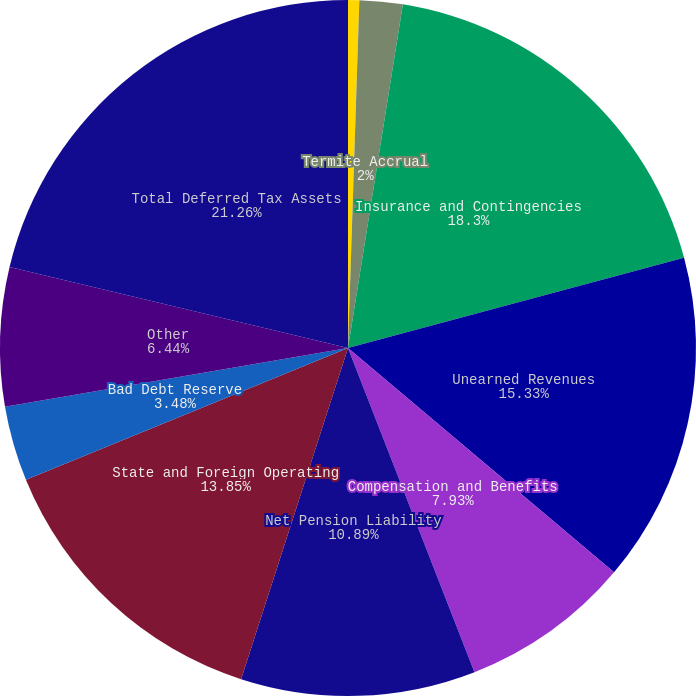Convert chart to OTSL. <chart><loc_0><loc_0><loc_500><loc_500><pie_chart><fcel>(in thousands)<fcel>Termite Accrual<fcel>Insurance and Contingencies<fcel>Unearned Revenues<fcel>Compensation and Benefits<fcel>Net Pension Liability<fcel>State and Foreign Operating<fcel>Bad Debt Reserve<fcel>Other<fcel>Total Deferred Tax Assets<nl><fcel>0.52%<fcel>2.0%<fcel>18.3%<fcel>15.33%<fcel>7.93%<fcel>10.89%<fcel>13.85%<fcel>3.48%<fcel>6.44%<fcel>21.26%<nl></chart> 